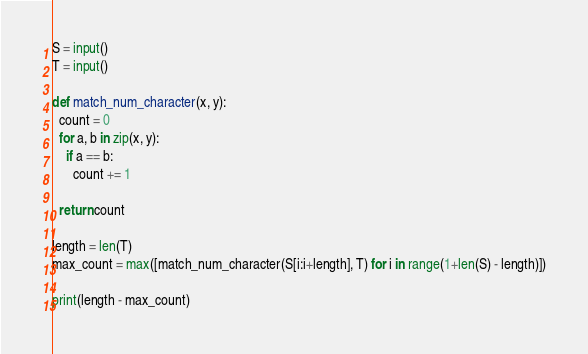<code> <loc_0><loc_0><loc_500><loc_500><_Python_>S = input()
T = input()
 
def match_num_character(x, y):
  count = 0
  for a, b in zip(x, y):
    if a == b:
      count += 1
      
  return count
 
length = len(T)
max_count = max([match_num_character(S[i:i+length], T) for i in range(1+len(S) - length)])
 
print(length - max_count)</code> 